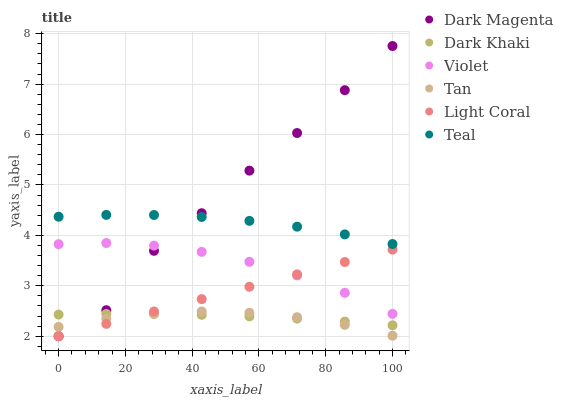Does Tan have the minimum area under the curve?
Answer yes or no. Yes. Does Dark Magenta have the maximum area under the curve?
Answer yes or no. Yes. Does Dark Khaki have the minimum area under the curve?
Answer yes or no. No. Does Dark Khaki have the maximum area under the curve?
Answer yes or no. No. Is Light Coral the smoothest?
Answer yes or no. Yes. Is Dark Magenta the roughest?
Answer yes or no. Yes. Is Dark Khaki the smoothest?
Answer yes or no. No. Is Dark Khaki the roughest?
Answer yes or no. No. Does Light Coral have the lowest value?
Answer yes or no. Yes. Does Dark Khaki have the lowest value?
Answer yes or no. No. Does Dark Magenta have the highest value?
Answer yes or no. Yes. Does Dark Khaki have the highest value?
Answer yes or no. No. Is Dark Khaki less than Teal?
Answer yes or no. Yes. Is Violet greater than Tan?
Answer yes or no. Yes. Does Teal intersect Dark Magenta?
Answer yes or no. Yes. Is Teal less than Dark Magenta?
Answer yes or no. No. Is Teal greater than Dark Magenta?
Answer yes or no. No. Does Dark Khaki intersect Teal?
Answer yes or no. No. 